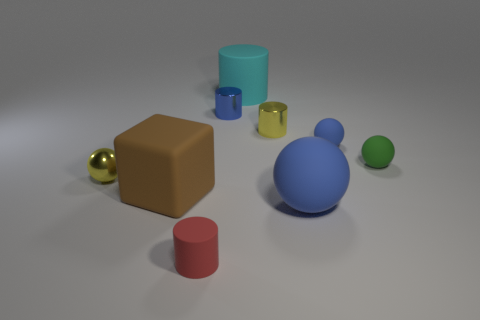What number of other objects are there of the same shape as the small green thing?
Keep it short and to the point. 3. There is a small object that is in front of the large cube; is its color the same as the large rubber object left of the cyan thing?
Offer a terse response. No. What size is the yellow thing on the right side of the cylinder in front of the metal object that is in front of the tiny yellow cylinder?
Your answer should be compact. Small. What shape is the blue object that is both on the right side of the cyan rubber cylinder and behind the cube?
Offer a very short reply. Sphere. Are there an equal number of small cylinders that are to the right of the red object and rubber cylinders that are in front of the tiny yellow metal cylinder?
Your answer should be very brief. No. Are there any gray things made of the same material as the green ball?
Your answer should be very brief. No. Is the material of the tiny cylinder that is on the left side of the blue shiny cylinder the same as the large cyan cylinder?
Offer a very short reply. Yes. There is a object that is in front of the tiny green ball and behind the brown object; what is its size?
Provide a succinct answer. Small. What color is the large rubber ball?
Provide a succinct answer. Blue. How many small gray rubber cylinders are there?
Provide a succinct answer. 0. 